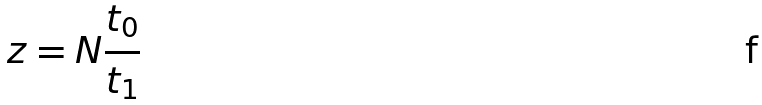<formula> <loc_0><loc_0><loc_500><loc_500>z = N \frac { t _ { 0 } } { t _ { 1 } }</formula> 